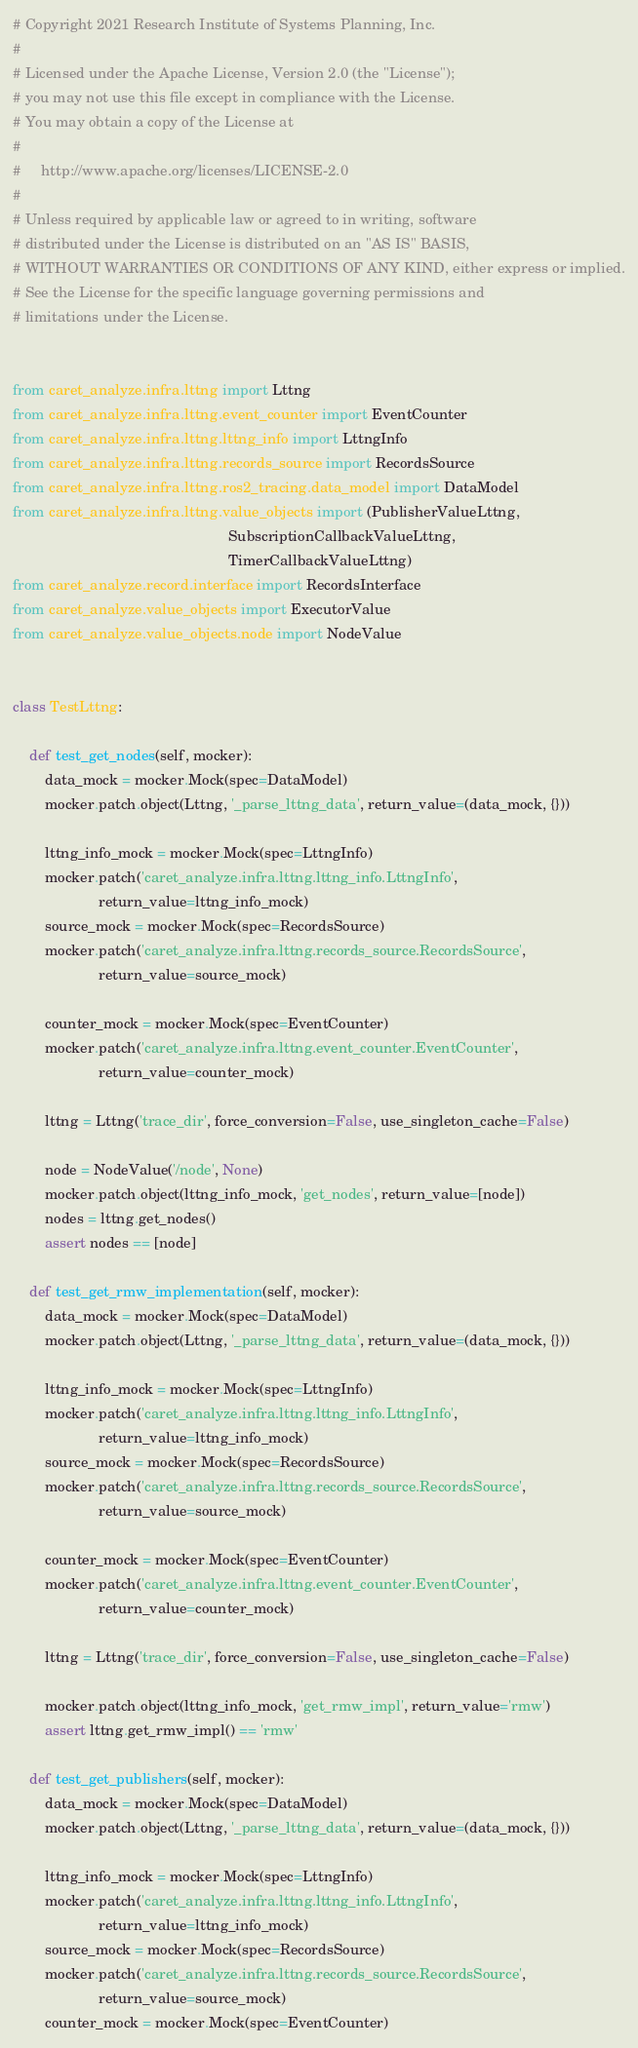<code> <loc_0><loc_0><loc_500><loc_500><_Python_># Copyright 2021 Research Institute of Systems Planning, Inc.
#
# Licensed under the Apache License, Version 2.0 (the "License");
# you may not use this file except in compliance with the License.
# You may obtain a copy of the License at
#
#     http://www.apache.org/licenses/LICENSE-2.0
#
# Unless required by applicable law or agreed to in writing, software
# distributed under the License is distributed on an "AS IS" BASIS,
# WITHOUT WARRANTIES OR CONDITIONS OF ANY KIND, either express or implied.
# See the License for the specific language governing permissions and
# limitations under the License.


from caret_analyze.infra.lttng import Lttng
from caret_analyze.infra.lttng.event_counter import EventCounter
from caret_analyze.infra.lttng.lttng_info import LttngInfo
from caret_analyze.infra.lttng.records_source import RecordsSource
from caret_analyze.infra.lttng.ros2_tracing.data_model import DataModel
from caret_analyze.infra.lttng.value_objects import (PublisherValueLttng,
                                                     SubscriptionCallbackValueLttng,
                                                     TimerCallbackValueLttng)
from caret_analyze.record.interface import RecordsInterface
from caret_analyze.value_objects import ExecutorValue
from caret_analyze.value_objects.node import NodeValue


class TestLttng:

    def test_get_nodes(self, mocker):
        data_mock = mocker.Mock(spec=DataModel)
        mocker.patch.object(Lttng, '_parse_lttng_data', return_value=(data_mock, {}))

        lttng_info_mock = mocker.Mock(spec=LttngInfo)
        mocker.patch('caret_analyze.infra.lttng.lttng_info.LttngInfo',
                     return_value=lttng_info_mock)
        source_mock = mocker.Mock(spec=RecordsSource)
        mocker.patch('caret_analyze.infra.lttng.records_source.RecordsSource',
                     return_value=source_mock)

        counter_mock = mocker.Mock(spec=EventCounter)
        mocker.patch('caret_analyze.infra.lttng.event_counter.EventCounter',
                     return_value=counter_mock)

        lttng = Lttng('trace_dir', force_conversion=False, use_singleton_cache=False)

        node = NodeValue('/node', None)
        mocker.patch.object(lttng_info_mock, 'get_nodes', return_value=[node])
        nodes = lttng.get_nodes()
        assert nodes == [node]

    def test_get_rmw_implementation(self, mocker):
        data_mock = mocker.Mock(spec=DataModel)
        mocker.patch.object(Lttng, '_parse_lttng_data', return_value=(data_mock, {}))

        lttng_info_mock = mocker.Mock(spec=LttngInfo)
        mocker.patch('caret_analyze.infra.lttng.lttng_info.LttngInfo',
                     return_value=lttng_info_mock)
        source_mock = mocker.Mock(spec=RecordsSource)
        mocker.patch('caret_analyze.infra.lttng.records_source.RecordsSource',
                     return_value=source_mock)

        counter_mock = mocker.Mock(spec=EventCounter)
        mocker.patch('caret_analyze.infra.lttng.event_counter.EventCounter',
                     return_value=counter_mock)

        lttng = Lttng('trace_dir', force_conversion=False, use_singleton_cache=False)

        mocker.patch.object(lttng_info_mock, 'get_rmw_impl', return_value='rmw')
        assert lttng.get_rmw_impl() == 'rmw'

    def test_get_publishers(self, mocker):
        data_mock = mocker.Mock(spec=DataModel)
        mocker.patch.object(Lttng, '_parse_lttng_data', return_value=(data_mock, {}))

        lttng_info_mock = mocker.Mock(spec=LttngInfo)
        mocker.patch('caret_analyze.infra.lttng.lttng_info.LttngInfo',
                     return_value=lttng_info_mock)
        source_mock = mocker.Mock(spec=RecordsSource)
        mocker.patch('caret_analyze.infra.lttng.records_source.RecordsSource',
                     return_value=source_mock)
        counter_mock = mocker.Mock(spec=EventCounter)</code> 